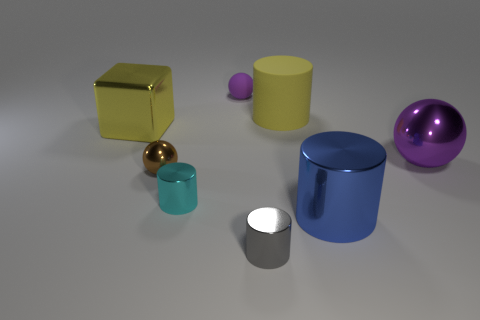Is there anything else that is the same color as the matte cylinder?
Make the answer very short. Yes. The large object that is the same color as the metal cube is what shape?
Make the answer very short. Cylinder. Do the large metallic cube and the big cylinder behind the small brown shiny thing have the same color?
Offer a very short reply. Yes. There is a cyan cylinder that is made of the same material as the small gray cylinder; what is its size?
Make the answer very short. Small. There is a object that is the same color as the big ball; what is its size?
Offer a terse response. Small. Does the big metallic ball have the same color as the small rubber sphere?
Give a very brief answer. Yes. Is there a yellow thing left of the tiny shiny cylinder that is behind the large cylinder in front of the large yellow matte cylinder?
Offer a terse response. Yes. How many cyan objects have the same size as the cube?
Make the answer very short. 0. There is a gray cylinder that is in front of the big yellow cube; is it the same size as the purple sphere that is on the right side of the tiny matte thing?
Give a very brief answer. No. There is a shiny object that is both on the left side of the big blue metallic thing and behind the tiny brown sphere; what is its shape?
Offer a terse response. Cube. 